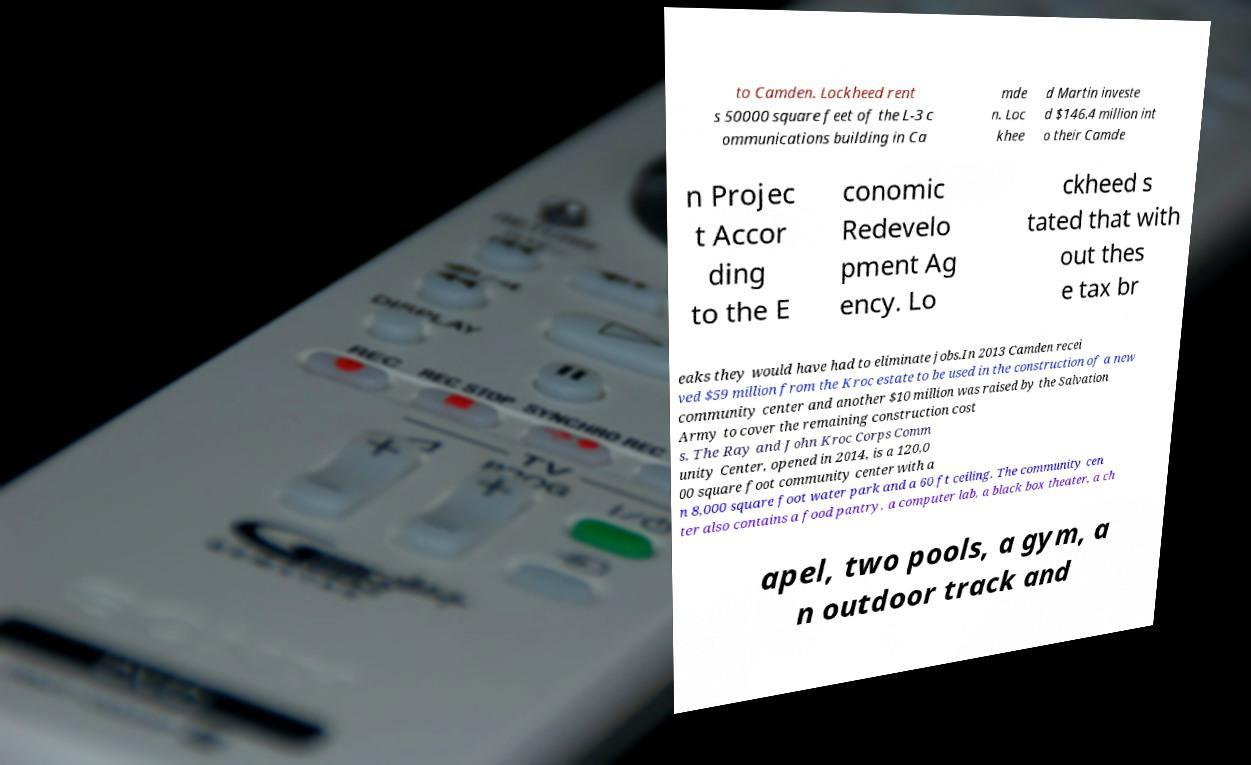Please read and relay the text visible in this image. What does it say? to Camden. Lockheed rent s 50000 square feet of the L-3 c ommunications building in Ca mde n. Loc khee d Martin investe d $146.4 million int o their Camde n Projec t Accor ding to the E conomic Redevelo pment Ag ency. Lo ckheed s tated that with out thes e tax br eaks they would have had to eliminate jobs.In 2013 Camden recei ved $59 million from the Kroc estate to be used in the construction of a new community center and another $10 million was raised by the Salvation Army to cover the remaining construction cost s. The Ray and John Kroc Corps Comm unity Center, opened in 2014, is a 120,0 00 square foot community center with a n 8,000 square foot water park and a 60 ft ceiling. The community cen ter also contains a food pantry, a computer lab, a black box theater, a ch apel, two pools, a gym, a n outdoor track and 